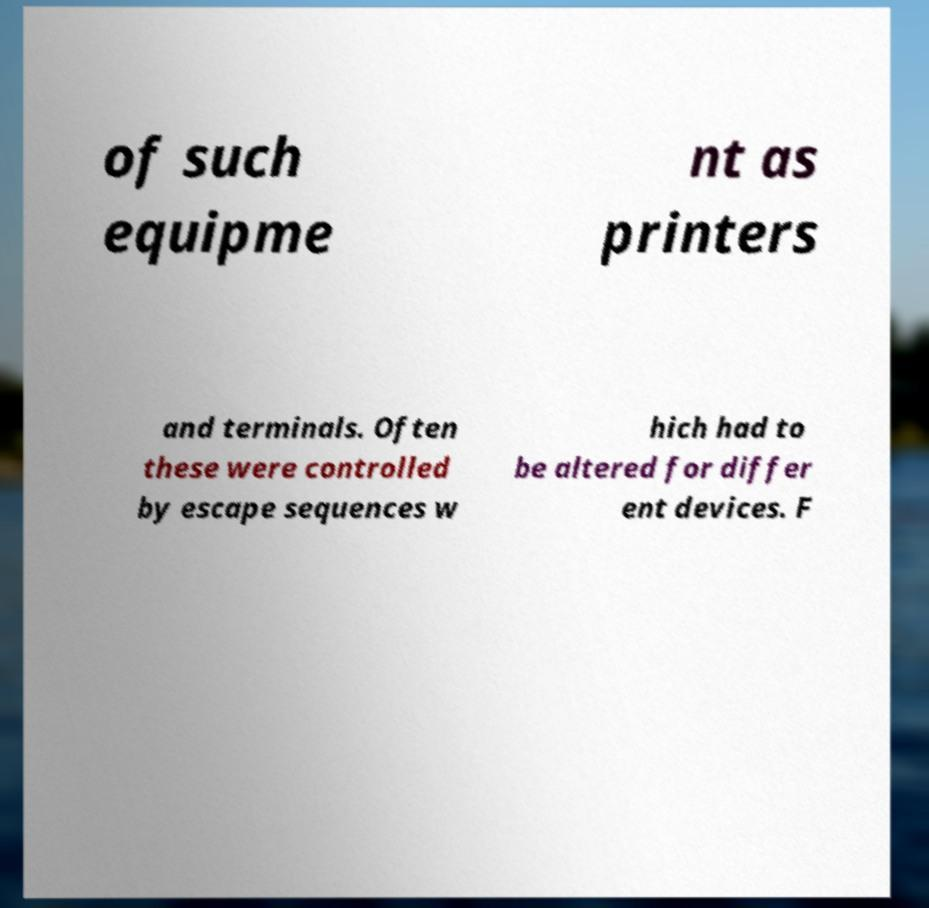Can you read and provide the text displayed in the image?This photo seems to have some interesting text. Can you extract and type it out for me? of such equipme nt as printers and terminals. Often these were controlled by escape sequences w hich had to be altered for differ ent devices. F 